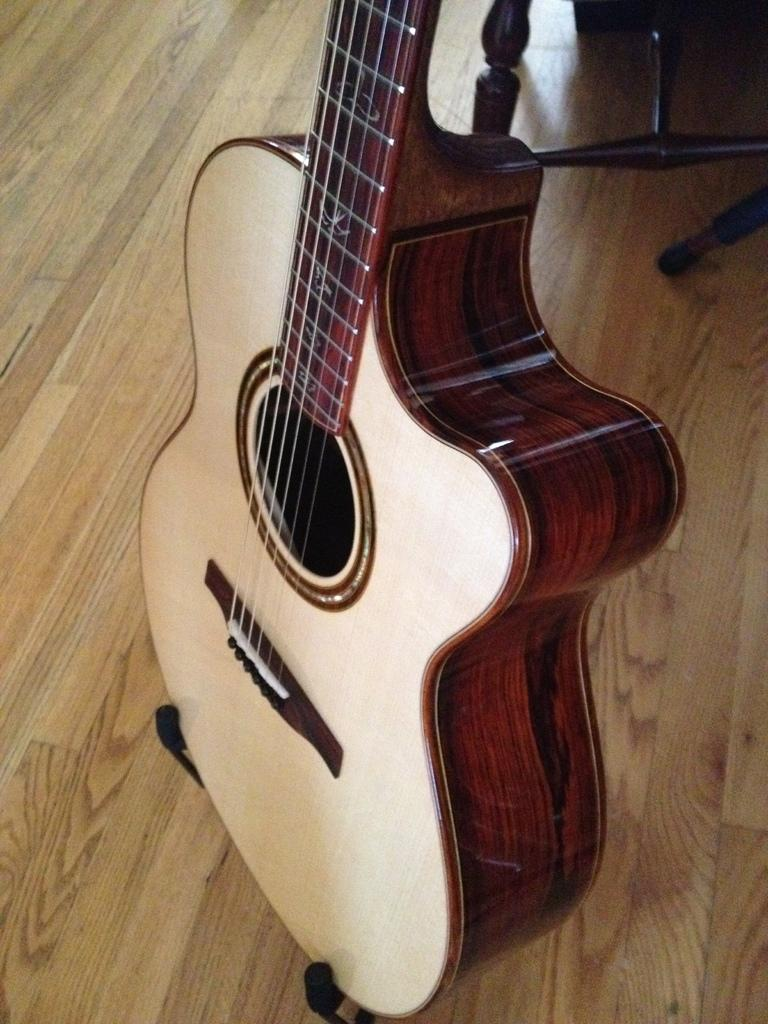What musical instrument is present in the image? There is a guitar in the image. What type of strings does the guitar have? The guitar in the image has six strings. What might someone be doing with the guitar in the image? Someone might be playing the guitar or holding it in the image. What is the girl's belief about the goose in the image? There is no girl or goose present in the image; it only features a guitar. 